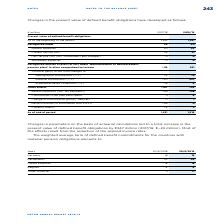According to Metro Ag's financial document, What are the changes in parameter based on? on the basis of actuarial calculations. The document states: "Changes in parameters on the basis of actuarial calculations led to a total increase in the..." Also, What did the changes in parameters on the basis of actuarial calculations lead to? a total increase in the present value of defined benefit obligations by €247 million (2017/18: €−24 million). Most of the effects result from the reduction of the applied invoice rates.. The document states: "ters on the basis of actuarial calculations led to a total increase in the present value of defined benefit obligations by €247 million (2017/18: €−24..." Also, The weighted average term of defined benefit commitments for which countries is provided? The document contains multiple relevant values: Germany, Netherlands, United Kingdom, Belgium, Other countries. From the document: "Germany 16 16 Netherlands 22 24 Other countries 11 11 Belgium 4 6 United Kingdom 18 18..." Additionally, In which year was the amount in Belgium larger? According to the financial document, 2019. The relevant text states: "Years 30/9/2018 30/9/2019..." Also, can you calculate: What was the change in the amount for Belgium in  FY2019 from FY2018? Based on the calculation: 6-4, the result is 2. This is based on the information: "Belgium 4 6 Belgium 4 6..." The key data points involved are: 4, 6. Also, can you calculate: What was the percentage change in the amount for Belgium in  FY2019 from FY2018? To answer this question, I need to perform calculations using the financial data. The calculation is: (6-4)/4, which equals 50 (percentage). This is based on the information: "Belgium 4 6 Belgium 4 6..." The key data points involved are: 4, 6. 